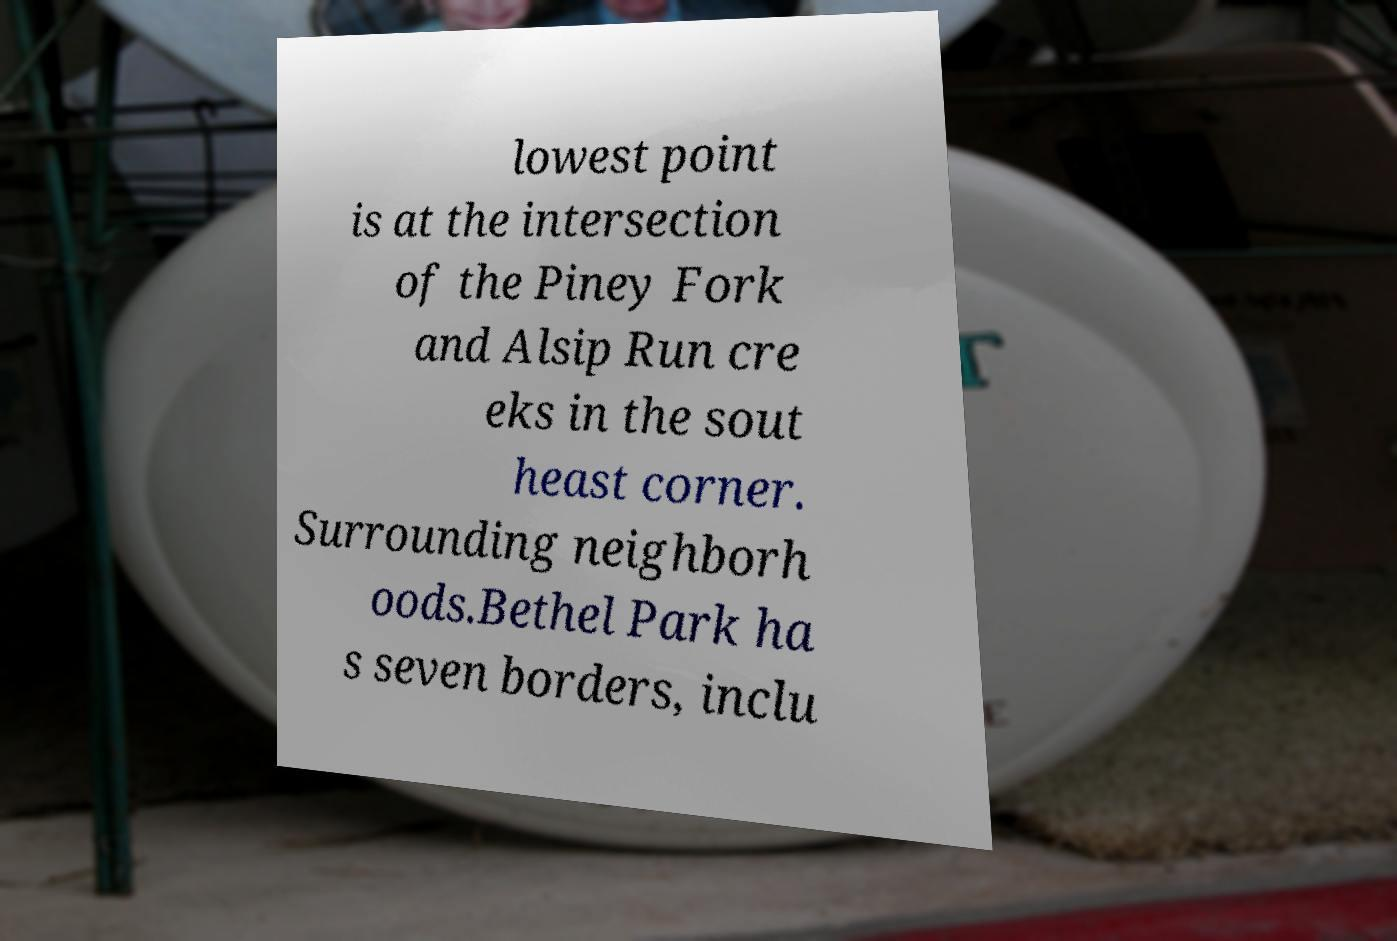Please identify and transcribe the text found in this image. lowest point is at the intersection of the Piney Fork and Alsip Run cre eks in the sout heast corner. Surrounding neighborh oods.Bethel Park ha s seven borders, inclu 